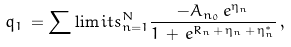<formula> <loc_0><loc_0><loc_500><loc_500>q _ { 1 } \, = \sum \lim i t s _ { n = 1 } ^ { N } \frac { - A _ { n _ { 0 } } \, e ^ { \eta _ { n } } } { 1 \, + \, e ^ { R _ { n } \, + \, \eta _ { n } \, + \, \eta _ { n } ^ { * } } } \, ,</formula> 